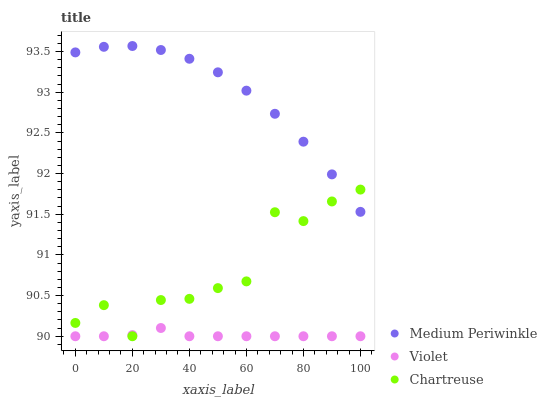Does Violet have the minimum area under the curve?
Answer yes or no. Yes. Does Medium Periwinkle have the maximum area under the curve?
Answer yes or no. Yes. Does Medium Periwinkle have the minimum area under the curve?
Answer yes or no. No. Does Violet have the maximum area under the curve?
Answer yes or no. No. Is Violet the smoothest?
Answer yes or no. Yes. Is Chartreuse the roughest?
Answer yes or no. Yes. Is Medium Periwinkle the smoothest?
Answer yes or no. No. Is Medium Periwinkle the roughest?
Answer yes or no. No. Does Chartreuse have the lowest value?
Answer yes or no. Yes. Does Medium Periwinkle have the lowest value?
Answer yes or no. No. Does Medium Periwinkle have the highest value?
Answer yes or no. Yes. Does Violet have the highest value?
Answer yes or no. No. Is Violet less than Medium Periwinkle?
Answer yes or no. Yes. Is Medium Periwinkle greater than Violet?
Answer yes or no. Yes. Does Violet intersect Chartreuse?
Answer yes or no. Yes. Is Violet less than Chartreuse?
Answer yes or no. No. Is Violet greater than Chartreuse?
Answer yes or no. No. Does Violet intersect Medium Periwinkle?
Answer yes or no. No. 